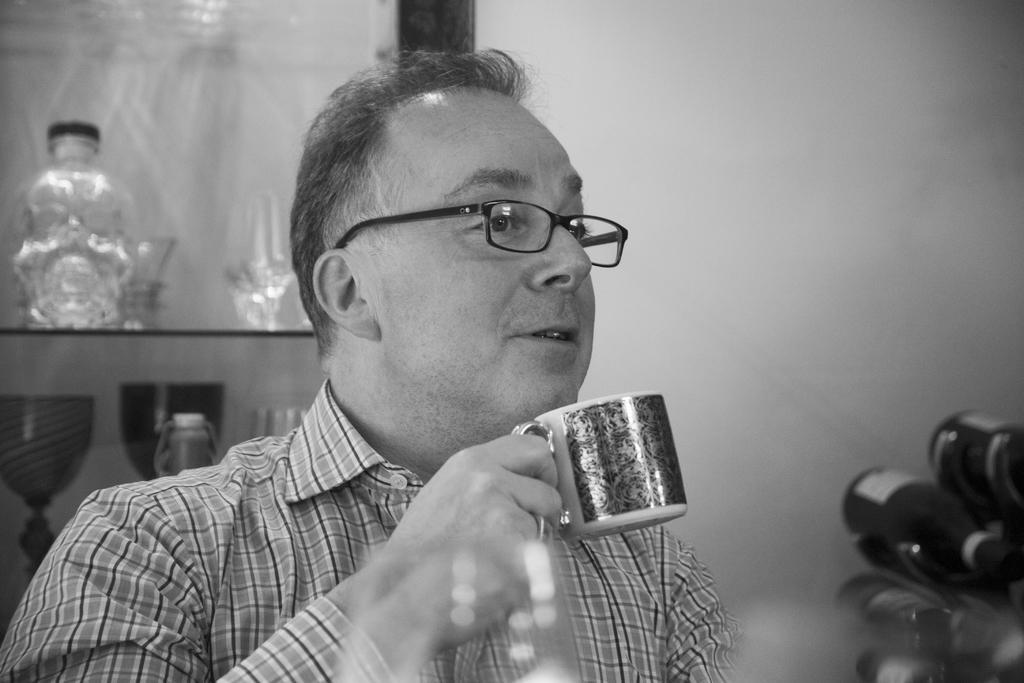In one or two sentences, can you explain what this image depicts? This is of a black and white image. I can see a man holding a cup. He is wearing a shirt and spectacles. At background I can see a glass bottle with a closed cap which is placed inside the cupboard ,and at the right corner of the image I can see another object. 